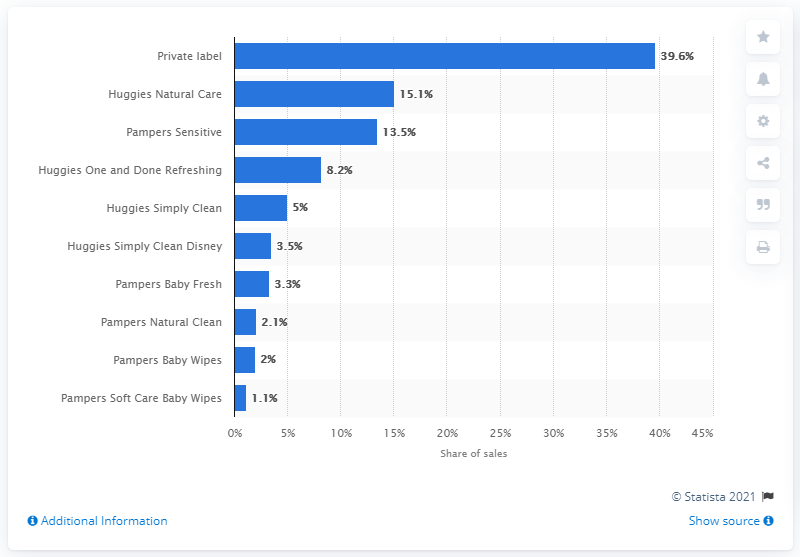Identify some key points in this picture. In 2016, Huggies Natural Care controlled approximately 15.1% of the baby wipes market. The sum of the first and last bar is 40.7. The highest blue bar represents private label products. 